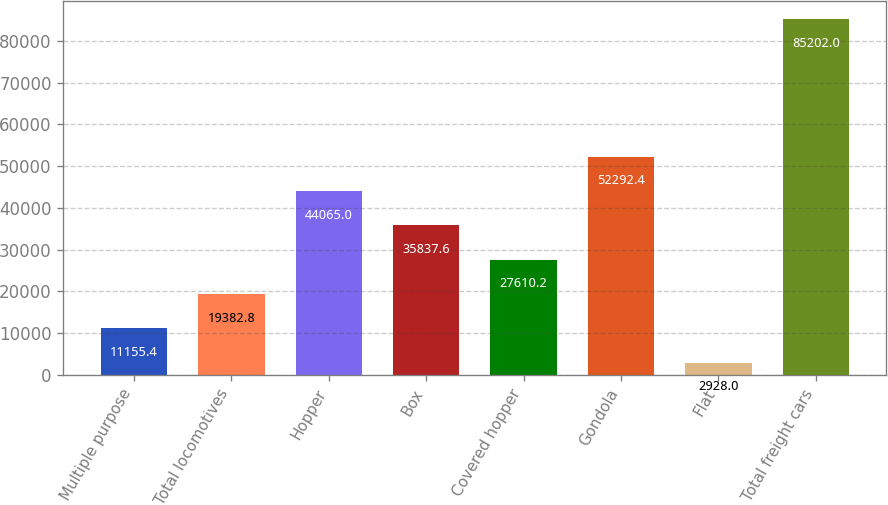Convert chart. <chart><loc_0><loc_0><loc_500><loc_500><bar_chart><fcel>Multiple purpose<fcel>Total locomotives<fcel>Hopper<fcel>Box<fcel>Covered hopper<fcel>Gondola<fcel>Flat<fcel>Total freight cars<nl><fcel>11155.4<fcel>19382.8<fcel>44065<fcel>35837.6<fcel>27610.2<fcel>52292.4<fcel>2928<fcel>85202<nl></chart> 